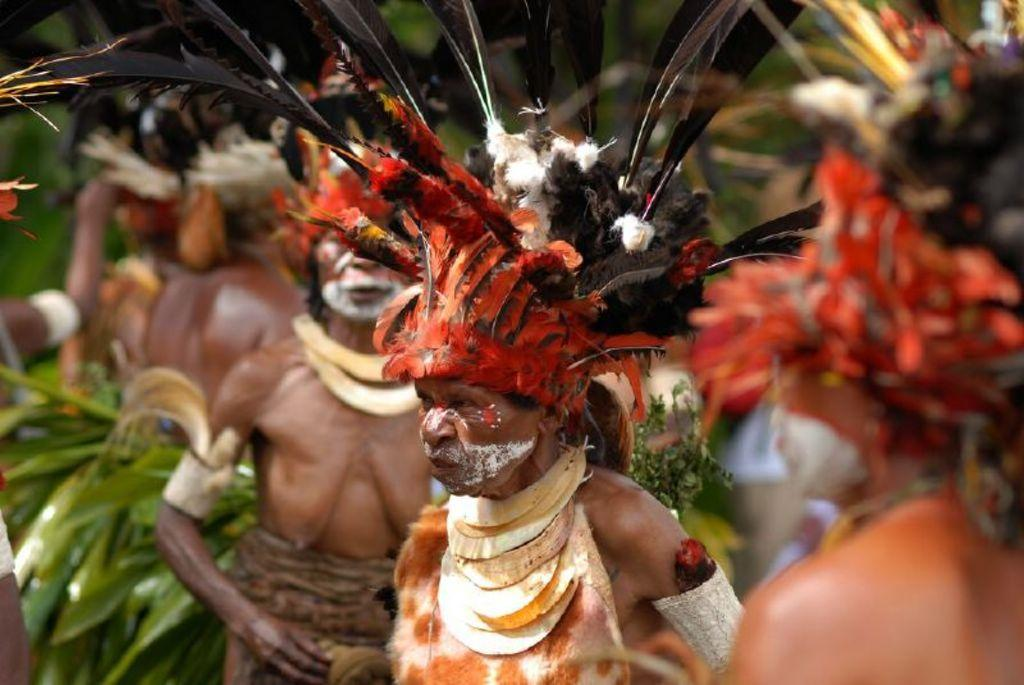Who or what is present in the image? There are people in the image. What are the people wearing on their heads? The people are wearing feather hats. Can you describe the background of the image? The background of the image is blurred. What type of bird can be seen on the farm in the image? There is no farm or bird present in the image; it features people wearing feather hats. Is there a lock visible on the door in the image? There is no door or lock present in the image. 